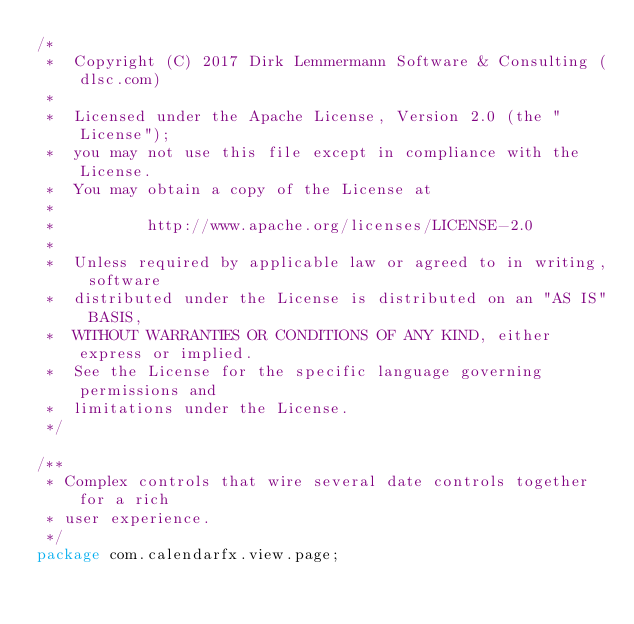<code> <loc_0><loc_0><loc_500><loc_500><_Java_>/*
 *  Copyright (C) 2017 Dirk Lemmermann Software & Consulting (dlsc.com)
 *
 *  Licensed under the Apache License, Version 2.0 (the "License");
 *  you may not use this file except in compliance with the License.
 *  You may obtain a copy of the License at
 *
 *          http://www.apache.org/licenses/LICENSE-2.0
 *
 *  Unless required by applicable law or agreed to in writing, software
 *  distributed under the License is distributed on an "AS IS" BASIS,
 *  WITHOUT WARRANTIES OR CONDITIONS OF ANY KIND, either express or implied.
 *  See the License for the specific language governing permissions and
 *  limitations under the License.
 */

/**
 * Complex controls that wire several date controls together for a rich
 * user experience.
 */
package com.calendarfx.view.page;

</code> 